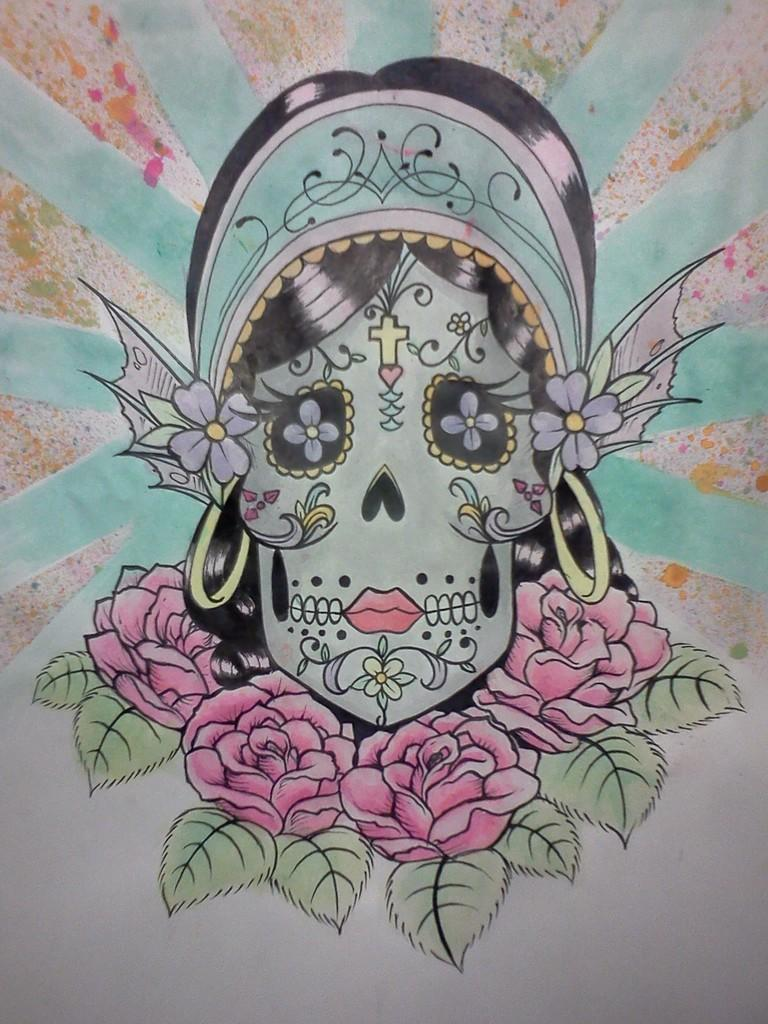What is present in the image that features a design or message? There is a poster in the image. What colors are used on the poster? The poster has green, black, red, and white colors. What is depicted on the poster? There is a person's face and flowers on the poster. What type of wood is used to create the person's face on the poster? There is no wood present in the image; the person's face is depicted on a poster with colors. How does the truck affect the design of the poster? There is no truck present in the image, so it does not affect the design of the poster. 